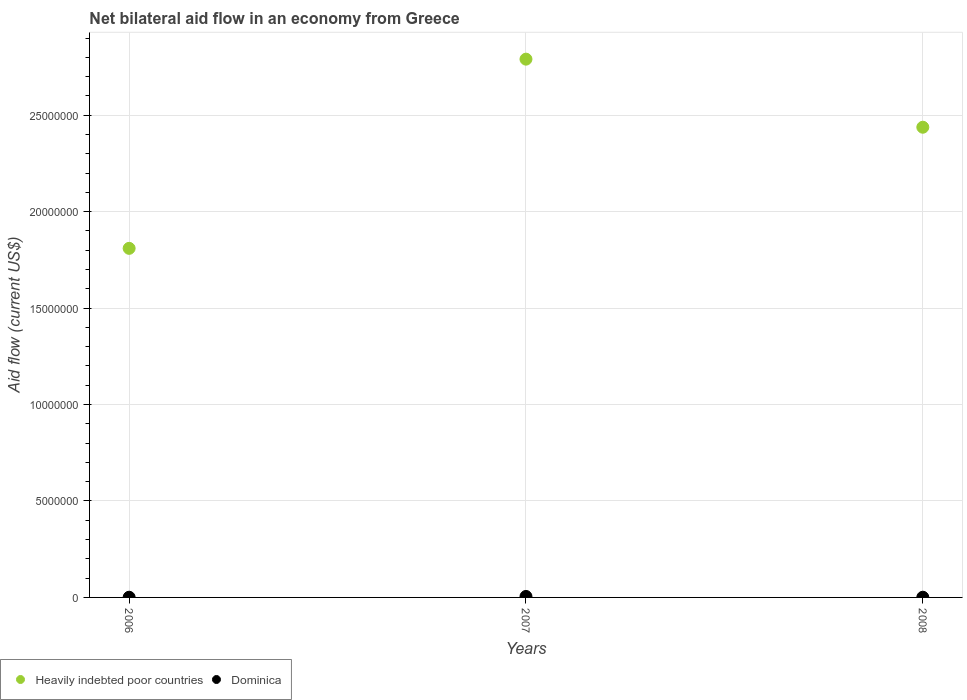What is the net bilateral aid flow in Heavily indebted poor countries in 2008?
Provide a short and direct response. 2.44e+07. Across all years, what is the maximum net bilateral aid flow in Heavily indebted poor countries?
Offer a very short reply. 2.79e+07. Across all years, what is the minimum net bilateral aid flow in Heavily indebted poor countries?
Provide a succinct answer. 1.81e+07. What is the total net bilateral aid flow in Heavily indebted poor countries in the graph?
Offer a very short reply. 7.04e+07. What is the difference between the net bilateral aid flow in Heavily indebted poor countries in 2007 and that in 2008?
Your answer should be compact. 3.53e+06. What is the difference between the net bilateral aid flow in Heavily indebted poor countries in 2006 and the net bilateral aid flow in Dominica in 2007?
Provide a short and direct response. 1.80e+07. What is the average net bilateral aid flow in Dominica per year?
Keep it short and to the point. 2.33e+04. In the year 2006, what is the difference between the net bilateral aid flow in Heavily indebted poor countries and net bilateral aid flow in Dominica?
Ensure brevity in your answer.  1.81e+07. Is the net bilateral aid flow in Heavily indebted poor countries in 2006 less than that in 2008?
Offer a very short reply. Yes. Is the difference between the net bilateral aid flow in Heavily indebted poor countries in 2006 and 2008 greater than the difference between the net bilateral aid flow in Dominica in 2006 and 2008?
Your response must be concise. No. What is the difference between the highest and the second highest net bilateral aid flow in Dominica?
Offer a terse response. 4.00e+04. In how many years, is the net bilateral aid flow in Heavily indebted poor countries greater than the average net bilateral aid flow in Heavily indebted poor countries taken over all years?
Your answer should be very brief. 2. Is the sum of the net bilateral aid flow in Dominica in 2007 and 2008 greater than the maximum net bilateral aid flow in Heavily indebted poor countries across all years?
Offer a terse response. No. Is the net bilateral aid flow in Dominica strictly less than the net bilateral aid flow in Heavily indebted poor countries over the years?
Your response must be concise. Yes. How many years are there in the graph?
Give a very brief answer. 3. Does the graph contain grids?
Your response must be concise. Yes. How many legend labels are there?
Offer a terse response. 2. What is the title of the graph?
Keep it short and to the point. Net bilateral aid flow in an economy from Greece. Does "Sint Maarten (Dutch part)" appear as one of the legend labels in the graph?
Provide a short and direct response. No. What is the label or title of the Y-axis?
Provide a short and direct response. Aid flow (current US$). What is the Aid flow (current US$) of Heavily indebted poor countries in 2006?
Make the answer very short. 1.81e+07. What is the Aid flow (current US$) in Dominica in 2006?
Your answer should be very brief. 10000. What is the Aid flow (current US$) of Heavily indebted poor countries in 2007?
Your answer should be very brief. 2.79e+07. What is the Aid flow (current US$) in Heavily indebted poor countries in 2008?
Ensure brevity in your answer.  2.44e+07. Across all years, what is the maximum Aid flow (current US$) in Heavily indebted poor countries?
Offer a very short reply. 2.79e+07. Across all years, what is the maximum Aid flow (current US$) of Dominica?
Offer a very short reply. 5.00e+04. Across all years, what is the minimum Aid flow (current US$) of Heavily indebted poor countries?
Your response must be concise. 1.81e+07. What is the total Aid flow (current US$) in Heavily indebted poor countries in the graph?
Offer a terse response. 7.04e+07. What is the total Aid flow (current US$) of Dominica in the graph?
Your response must be concise. 7.00e+04. What is the difference between the Aid flow (current US$) of Heavily indebted poor countries in 2006 and that in 2007?
Provide a succinct answer. -9.81e+06. What is the difference between the Aid flow (current US$) in Dominica in 2006 and that in 2007?
Provide a succinct answer. -4.00e+04. What is the difference between the Aid flow (current US$) in Heavily indebted poor countries in 2006 and that in 2008?
Provide a short and direct response. -6.28e+06. What is the difference between the Aid flow (current US$) in Dominica in 2006 and that in 2008?
Your answer should be compact. 0. What is the difference between the Aid flow (current US$) in Heavily indebted poor countries in 2007 and that in 2008?
Provide a succinct answer. 3.53e+06. What is the difference between the Aid flow (current US$) in Dominica in 2007 and that in 2008?
Give a very brief answer. 4.00e+04. What is the difference between the Aid flow (current US$) of Heavily indebted poor countries in 2006 and the Aid flow (current US$) of Dominica in 2007?
Make the answer very short. 1.80e+07. What is the difference between the Aid flow (current US$) of Heavily indebted poor countries in 2006 and the Aid flow (current US$) of Dominica in 2008?
Your answer should be compact. 1.81e+07. What is the difference between the Aid flow (current US$) of Heavily indebted poor countries in 2007 and the Aid flow (current US$) of Dominica in 2008?
Offer a terse response. 2.79e+07. What is the average Aid flow (current US$) of Heavily indebted poor countries per year?
Your answer should be very brief. 2.35e+07. What is the average Aid flow (current US$) in Dominica per year?
Offer a very short reply. 2.33e+04. In the year 2006, what is the difference between the Aid flow (current US$) in Heavily indebted poor countries and Aid flow (current US$) in Dominica?
Ensure brevity in your answer.  1.81e+07. In the year 2007, what is the difference between the Aid flow (current US$) of Heavily indebted poor countries and Aid flow (current US$) of Dominica?
Provide a short and direct response. 2.79e+07. In the year 2008, what is the difference between the Aid flow (current US$) of Heavily indebted poor countries and Aid flow (current US$) of Dominica?
Your response must be concise. 2.44e+07. What is the ratio of the Aid flow (current US$) in Heavily indebted poor countries in 2006 to that in 2007?
Provide a succinct answer. 0.65. What is the ratio of the Aid flow (current US$) of Heavily indebted poor countries in 2006 to that in 2008?
Provide a short and direct response. 0.74. What is the ratio of the Aid flow (current US$) in Dominica in 2006 to that in 2008?
Give a very brief answer. 1. What is the ratio of the Aid flow (current US$) in Heavily indebted poor countries in 2007 to that in 2008?
Offer a terse response. 1.14. What is the ratio of the Aid flow (current US$) of Dominica in 2007 to that in 2008?
Your answer should be very brief. 5. What is the difference between the highest and the second highest Aid flow (current US$) in Heavily indebted poor countries?
Make the answer very short. 3.53e+06. What is the difference between the highest and the second highest Aid flow (current US$) of Dominica?
Provide a short and direct response. 4.00e+04. What is the difference between the highest and the lowest Aid flow (current US$) in Heavily indebted poor countries?
Ensure brevity in your answer.  9.81e+06. What is the difference between the highest and the lowest Aid flow (current US$) in Dominica?
Give a very brief answer. 4.00e+04. 